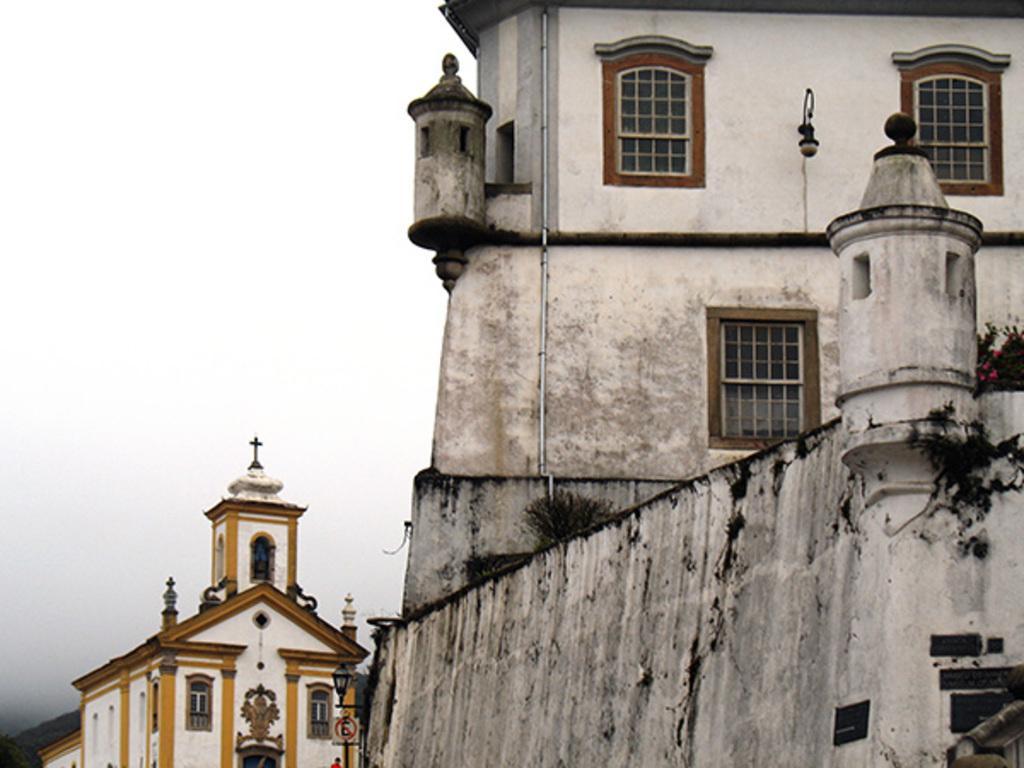Please provide a concise description of this image. In this image there are two buildings one is very much new in white colour and other one is very old. 